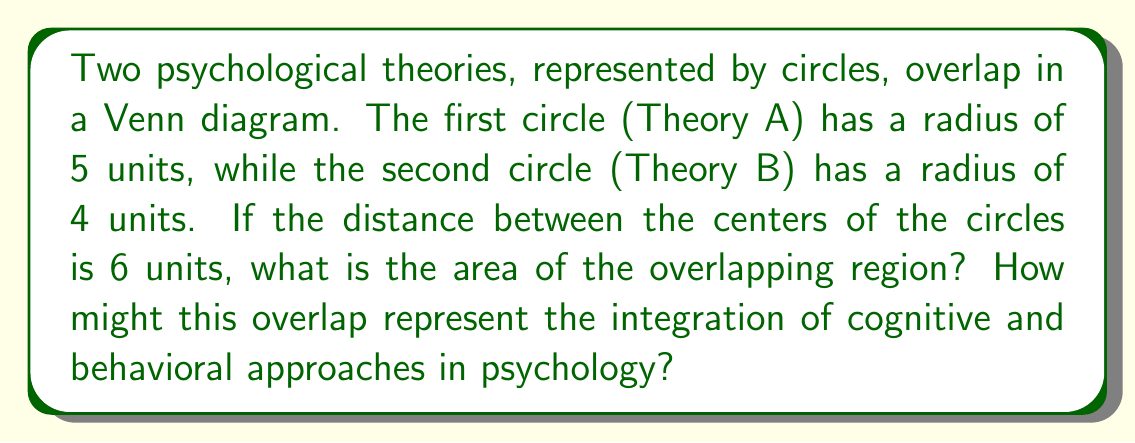Help me with this question. To solve this problem, we'll use the formula for the area of intersection between two circles. Let's break it down step-by-step:

1) First, we need to calculate the distance from the center of each circle to the line of intersection. We can do this using the Pythagorean theorem:

   Let $a$ be the distance from the center of circle A to the intersection line,
   and $b$ be the distance from the center of circle B to the intersection line.

   $a^2 + b^2 = 6^2$
   $a^2 + b^2 = 36$
   $5^2 - a^2 = 4^2 - b^2$
   $25 - a^2 = 16 - b^2$
   $b^2 = a^2 + 9$

2) Substituting this into the first equation:

   $a^2 + (a^2 + 9) = 36$
   $2a^2 = 27$
   $a^2 = 13.5$
   $a = \sqrt{13.5} \approx 3.674$

3) We can now find $b$:

   $b^2 = 36 - 13.5 = 22.5$
   $b = \sqrt{22.5} \approx 4.743$

4) The area of intersection is given by:

   $A = r_1^2 \arccos(\frac{a}{r_1}) + r_2^2 \arccos(\frac{b}{r_2}) - ab$

   Where $r_1 = 5$ and $r_2 = 4$

5) Substituting the values:

   $A = 5^2 \arccos(\frac{3.674}{5}) + 4^2 \arccos(\frac{4.743}{4}) - 3.674 * 4.743$

6) Calculating:

   $A \approx 25 * 0.8391 + 16 * 0.3218 - 17.4258$
   $A \approx 20.9775 + 5.1488 - 17.4258$
   $A \approx 8.7005$ square units

This overlap could represent the shared concepts and methodologies between cognitive and behavioral approaches in psychology, such as how cognitive processes influence behavior and how behavior can shape cognition.
Answer: $8.7005$ square units 